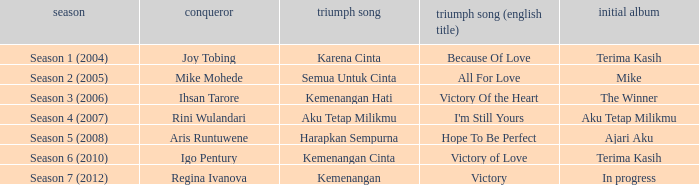Write the full table. {'header': ['season', 'conqueror', 'triumph song', 'triumph song (english title)', 'initial album'], 'rows': [['Season 1 (2004)', 'Joy Tobing', 'Karena Cinta', 'Because Of Love', 'Terima Kasih'], ['Season 2 (2005)', 'Mike Mohede', 'Semua Untuk Cinta', 'All For Love', 'Mike'], ['Season 3 (2006)', 'Ihsan Tarore', 'Kemenangan Hati', 'Victory Of the Heart', 'The Winner'], ['Season 4 (2007)', 'Rini Wulandari', 'Aku Tetap Milikmu', "I'm Still Yours", 'Aku Tetap Milikmu'], ['Season 5 (2008)', 'Aris Runtuwene', 'Harapkan Sempurna', 'Hope To Be Perfect', 'Ajari Aku'], ['Season 6 (2010)', 'Igo Pentury', 'Kemenangan Cinta', 'Victory of Love', 'Terima Kasih'], ['Season 7 (2012)', 'Regina Ivanova', 'Kemenangan', 'Victory', 'In progress']]} Which English winning song had the winner aris runtuwene? Hope To Be Perfect. 